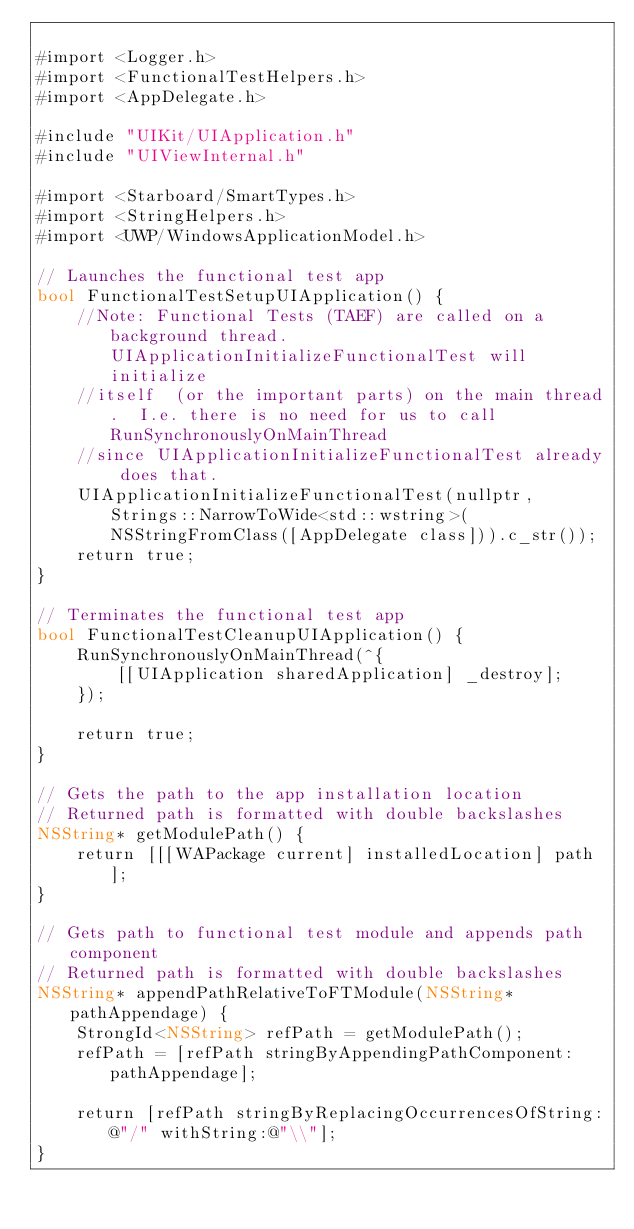Convert code to text. <code><loc_0><loc_0><loc_500><loc_500><_ObjectiveC_>
#import <Logger.h>
#import <FunctionalTestHelpers.h>
#import <AppDelegate.h>

#include "UIKit/UIApplication.h"
#include "UIViewInternal.h"

#import <Starboard/SmartTypes.h>
#import <StringHelpers.h>
#import <UWP/WindowsApplicationModel.h>

// Launches the functional test app
bool FunctionalTestSetupUIApplication() {
    //Note: Functional Tests (TAEF) are called on a background thread.  UIApplicationInitializeFunctionalTest will initialize 
    //itself  (or the important parts) on the main thread.  I.e. there is no need for us to call RunSynchronouslyOnMainThread 
    //since UIApplicationInitializeFunctionalTest already does that.
    UIApplicationInitializeFunctionalTest(nullptr, Strings::NarrowToWide<std::wstring>(NSStringFromClass([AppDelegate class])).c_str());
    return true;
}

// Terminates the functional test app
bool FunctionalTestCleanupUIApplication() {
    RunSynchronouslyOnMainThread(^{
        [[UIApplication sharedApplication] _destroy];
    });

    return true;
}

// Gets the path to the app installation location
// Returned path is formatted with double backslashes
NSString* getModulePath() {
    return [[[WAPackage current] installedLocation] path];
}

// Gets path to functional test module and appends path component
// Returned path is formatted with double backslashes
NSString* appendPathRelativeToFTModule(NSString* pathAppendage) {
    StrongId<NSString> refPath = getModulePath();
    refPath = [refPath stringByAppendingPathComponent:pathAppendage];

    return [refPath stringByReplacingOccurrencesOfString:@"/" withString:@"\\"];
}
</code> 